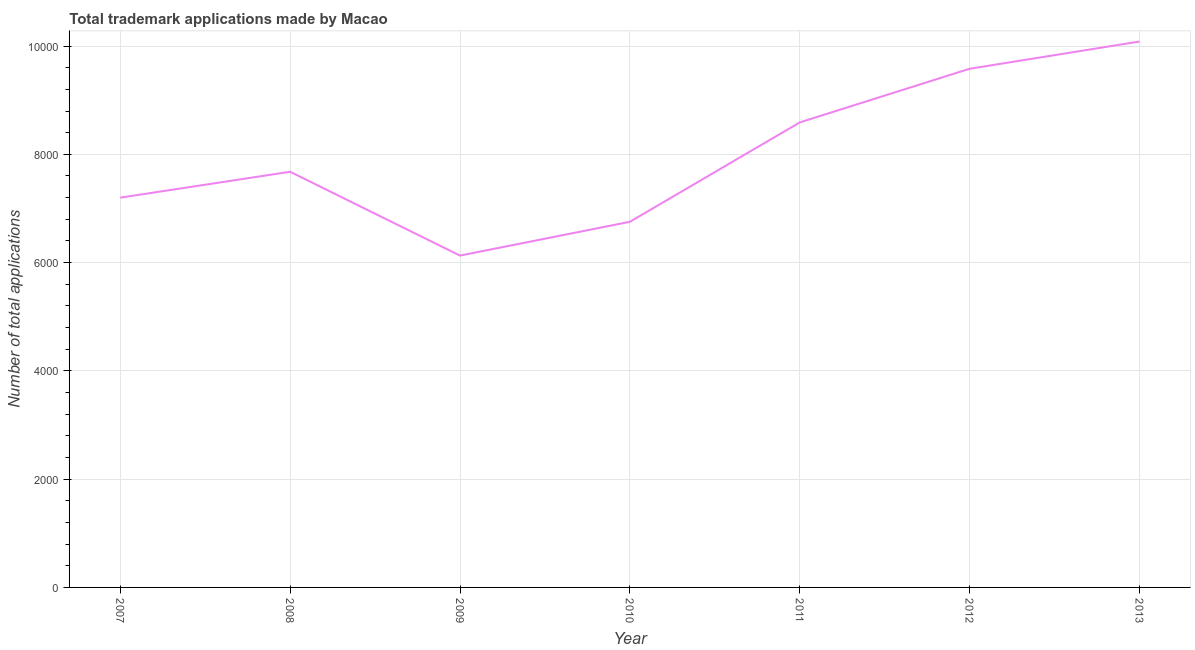What is the number of trademark applications in 2008?
Provide a succinct answer. 7678. Across all years, what is the maximum number of trademark applications?
Provide a short and direct response. 1.01e+04. Across all years, what is the minimum number of trademark applications?
Offer a terse response. 6130. In which year was the number of trademark applications minimum?
Your response must be concise. 2009. What is the sum of the number of trademark applications?
Ensure brevity in your answer.  5.60e+04. What is the difference between the number of trademark applications in 2007 and 2011?
Keep it short and to the point. -1390. What is the average number of trademark applications per year?
Make the answer very short. 8002.43. What is the median number of trademark applications?
Your answer should be very brief. 7678. What is the ratio of the number of trademark applications in 2009 to that in 2013?
Make the answer very short. 0.61. Is the difference between the number of trademark applications in 2007 and 2012 greater than the difference between any two years?
Offer a terse response. No. What is the difference between the highest and the second highest number of trademark applications?
Provide a succinct answer. 503. Is the sum of the number of trademark applications in 2008 and 2012 greater than the maximum number of trademark applications across all years?
Ensure brevity in your answer.  Yes. What is the difference between the highest and the lowest number of trademark applications?
Offer a very short reply. 3954. In how many years, is the number of trademark applications greater than the average number of trademark applications taken over all years?
Your response must be concise. 3. Does the number of trademark applications monotonically increase over the years?
Your answer should be very brief. No. How many lines are there?
Offer a very short reply. 1. Does the graph contain any zero values?
Your response must be concise. No. Does the graph contain grids?
Give a very brief answer. Yes. What is the title of the graph?
Offer a very short reply. Total trademark applications made by Macao. What is the label or title of the Y-axis?
Offer a terse response. Number of total applications. What is the Number of total applications of 2007?
Your response must be concise. 7200. What is the Number of total applications of 2008?
Give a very brief answer. 7678. What is the Number of total applications of 2009?
Ensure brevity in your answer.  6130. What is the Number of total applications in 2010?
Give a very brief answer. 6754. What is the Number of total applications in 2011?
Make the answer very short. 8590. What is the Number of total applications in 2012?
Give a very brief answer. 9581. What is the Number of total applications of 2013?
Your answer should be very brief. 1.01e+04. What is the difference between the Number of total applications in 2007 and 2008?
Your response must be concise. -478. What is the difference between the Number of total applications in 2007 and 2009?
Your answer should be compact. 1070. What is the difference between the Number of total applications in 2007 and 2010?
Your response must be concise. 446. What is the difference between the Number of total applications in 2007 and 2011?
Offer a terse response. -1390. What is the difference between the Number of total applications in 2007 and 2012?
Your answer should be very brief. -2381. What is the difference between the Number of total applications in 2007 and 2013?
Keep it short and to the point. -2884. What is the difference between the Number of total applications in 2008 and 2009?
Your answer should be very brief. 1548. What is the difference between the Number of total applications in 2008 and 2010?
Give a very brief answer. 924. What is the difference between the Number of total applications in 2008 and 2011?
Provide a succinct answer. -912. What is the difference between the Number of total applications in 2008 and 2012?
Offer a terse response. -1903. What is the difference between the Number of total applications in 2008 and 2013?
Keep it short and to the point. -2406. What is the difference between the Number of total applications in 2009 and 2010?
Give a very brief answer. -624. What is the difference between the Number of total applications in 2009 and 2011?
Give a very brief answer. -2460. What is the difference between the Number of total applications in 2009 and 2012?
Provide a succinct answer. -3451. What is the difference between the Number of total applications in 2009 and 2013?
Ensure brevity in your answer.  -3954. What is the difference between the Number of total applications in 2010 and 2011?
Provide a short and direct response. -1836. What is the difference between the Number of total applications in 2010 and 2012?
Provide a succinct answer. -2827. What is the difference between the Number of total applications in 2010 and 2013?
Provide a succinct answer. -3330. What is the difference between the Number of total applications in 2011 and 2012?
Give a very brief answer. -991. What is the difference between the Number of total applications in 2011 and 2013?
Offer a very short reply. -1494. What is the difference between the Number of total applications in 2012 and 2013?
Offer a very short reply. -503. What is the ratio of the Number of total applications in 2007 to that in 2008?
Offer a terse response. 0.94. What is the ratio of the Number of total applications in 2007 to that in 2009?
Give a very brief answer. 1.18. What is the ratio of the Number of total applications in 2007 to that in 2010?
Give a very brief answer. 1.07. What is the ratio of the Number of total applications in 2007 to that in 2011?
Keep it short and to the point. 0.84. What is the ratio of the Number of total applications in 2007 to that in 2012?
Provide a succinct answer. 0.75. What is the ratio of the Number of total applications in 2007 to that in 2013?
Give a very brief answer. 0.71. What is the ratio of the Number of total applications in 2008 to that in 2009?
Offer a very short reply. 1.25. What is the ratio of the Number of total applications in 2008 to that in 2010?
Keep it short and to the point. 1.14. What is the ratio of the Number of total applications in 2008 to that in 2011?
Offer a very short reply. 0.89. What is the ratio of the Number of total applications in 2008 to that in 2012?
Provide a succinct answer. 0.8. What is the ratio of the Number of total applications in 2008 to that in 2013?
Give a very brief answer. 0.76. What is the ratio of the Number of total applications in 2009 to that in 2010?
Provide a succinct answer. 0.91. What is the ratio of the Number of total applications in 2009 to that in 2011?
Provide a succinct answer. 0.71. What is the ratio of the Number of total applications in 2009 to that in 2012?
Keep it short and to the point. 0.64. What is the ratio of the Number of total applications in 2009 to that in 2013?
Ensure brevity in your answer.  0.61. What is the ratio of the Number of total applications in 2010 to that in 2011?
Make the answer very short. 0.79. What is the ratio of the Number of total applications in 2010 to that in 2012?
Offer a very short reply. 0.7. What is the ratio of the Number of total applications in 2010 to that in 2013?
Provide a succinct answer. 0.67. What is the ratio of the Number of total applications in 2011 to that in 2012?
Your answer should be compact. 0.9. What is the ratio of the Number of total applications in 2011 to that in 2013?
Offer a terse response. 0.85. 